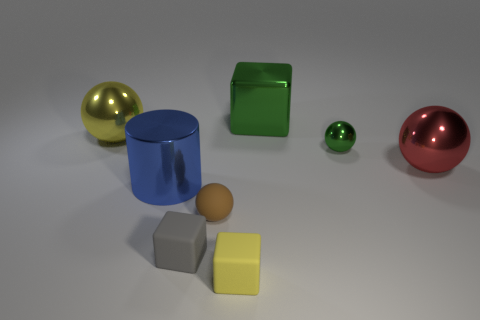Subtract all small green shiny spheres. How many spheres are left? 3 Subtract 1 cylinders. How many cylinders are left? 0 Add 4 small brown spheres. How many small brown spheres are left? 5 Add 6 large red shiny objects. How many large red shiny objects exist? 7 Add 1 big blue metallic spheres. How many objects exist? 9 Subtract all brown spheres. How many spheres are left? 3 Subtract 1 blue cylinders. How many objects are left? 7 Subtract all cylinders. How many objects are left? 7 Subtract all cyan balls. Subtract all red cylinders. How many balls are left? 4 Subtract all purple blocks. How many cyan spheres are left? 0 